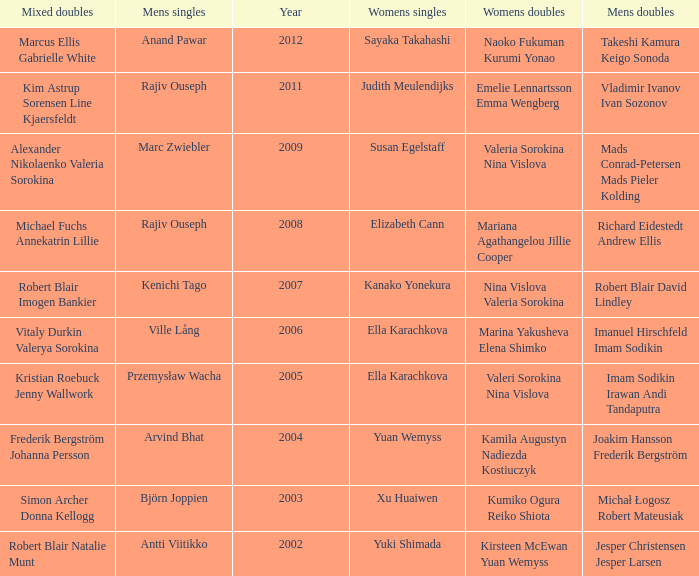What is the mens singles of 2008? Rajiv Ouseph. 